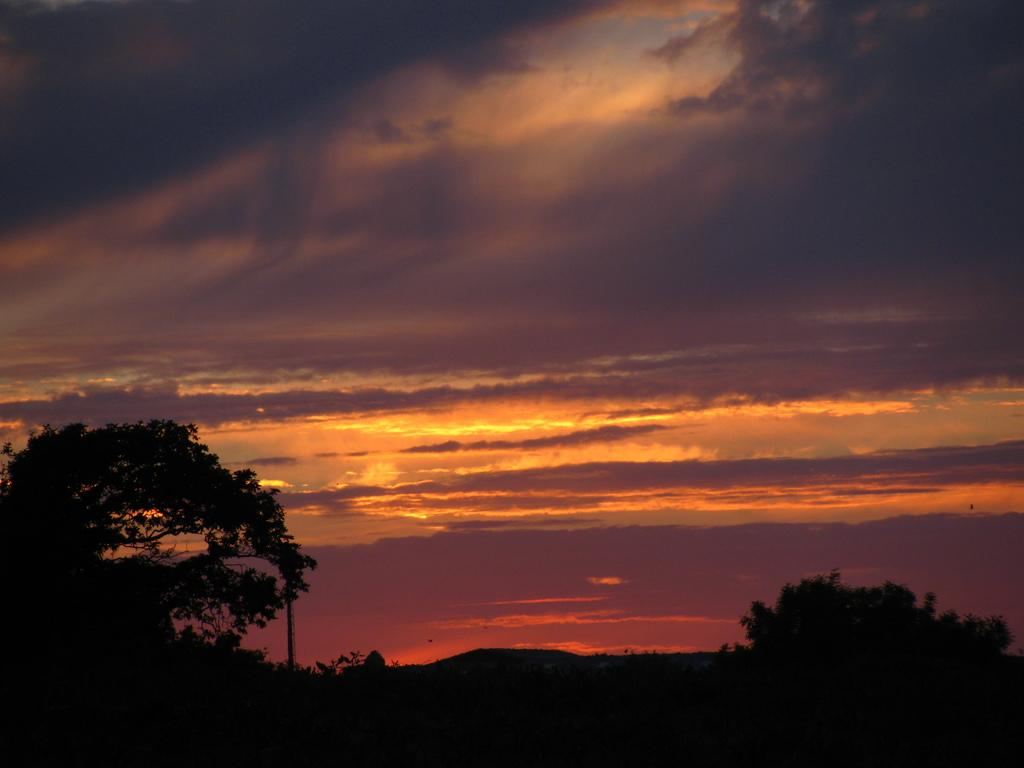What type of vegetation can be seen in the image? There are trees in the image. What part of the natural environment is visible in the image? The sky is visible in the background of the image. How many sisters are present in the image? There is no mention of a sister or any people in the image; it features trees and the sky. What type of beetle can be seen crawling on the leaves of the trees in the image? There is no beetle present in the image; it only features trees and the sky. 